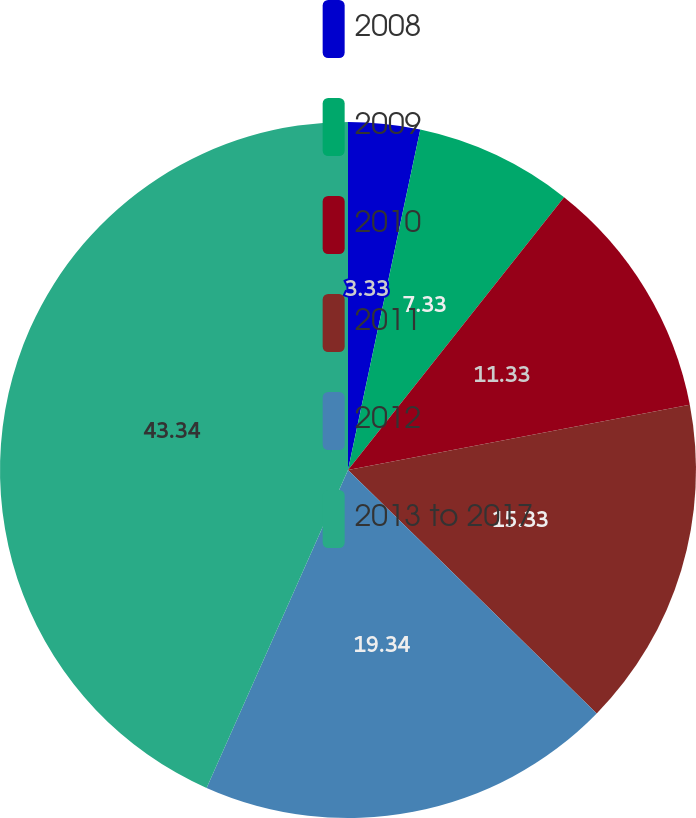<chart> <loc_0><loc_0><loc_500><loc_500><pie_chart><fcel>2008<fcel>2009<fcel>2010<fcel>2011<fcel>2012<fcel>2013 to 2017<nl><fcel>3.33%<fcel>7.33%<fcel>11.33%<fcel>15.33%<fcel>19.33%<fcel>43.33%<nl></chart> 